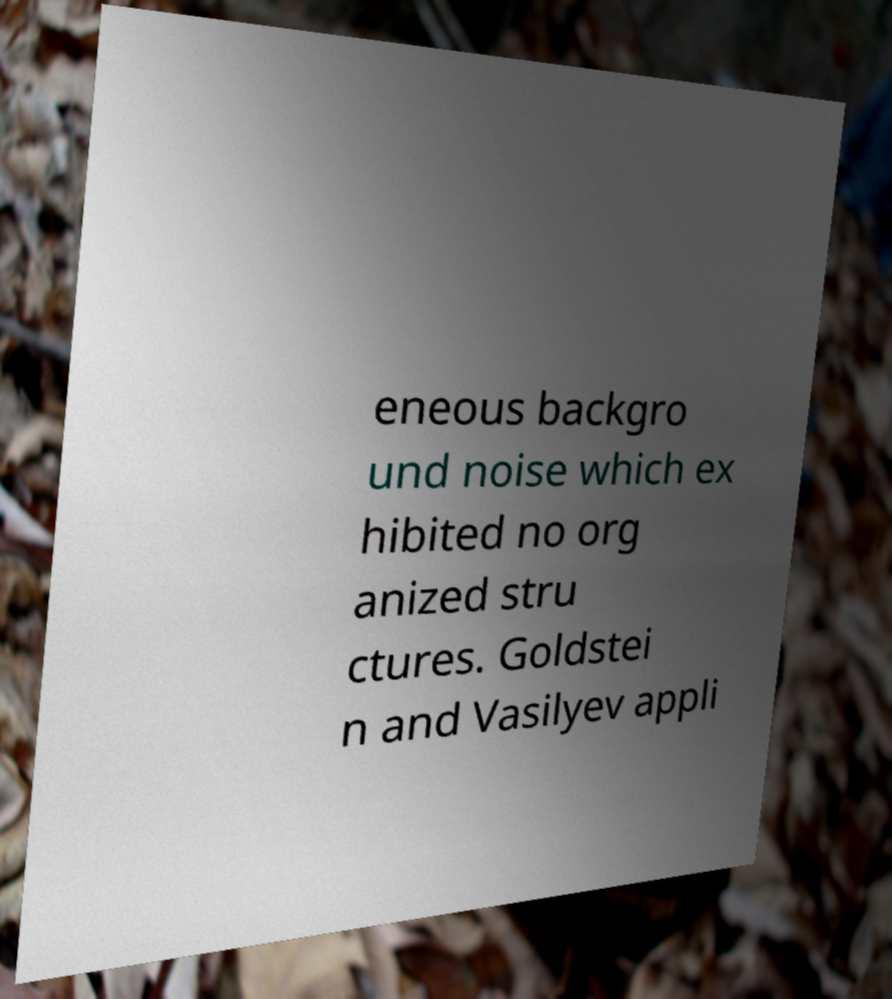There's text embedded in this image that I need extracted. Can you transcribe it verbatim? eneous backgro und noise which ex hibited no org anized stru ctures. Goldstei n and Vasilyev appli 